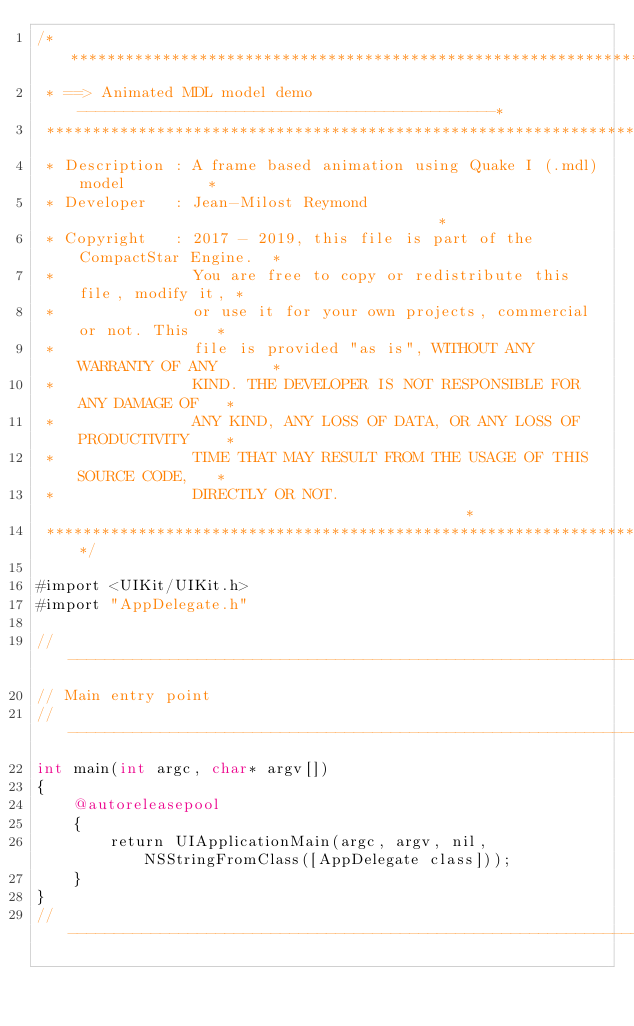<code> <loc_0><loc_0><loc_500><loc_500><_ObjectiveC_>/****************************************************************************
 * ==> Animated MDL model demo ---------------------------------------------*
 ****************************************************************************
 * Description : A frame based animation using Quake I (.mdl) model         *
 * Developer   : Jean-Milost Reymond                                        *
 * Copyright   : 2017 - 2019, this file is part of the CompactStar Engine.  *
 *               You are free to copy or redistribute this file, modify it, *
 *               or use it for your own projects, commercial or not. This   *
 *               file is provided "as is", WITHOUT ANY WARRANTY OF ANY      *
 *               KIND. THE DEVELOPER IS NOT RESPONSIBLE FOR ANY DAMAGE OF   *
 *               ANY KIND, ANY LOSS OF DATA, OR ANY LOSS OF PRODUCTIVITY    *
 *               TIME THAT MAY RESULT FROM THE USAGE OF THIS SOURCE CODE,   *
 *               DIRECTLY OR NOT.                                           *
 ****************************************************************************/

#import <UIKit/UIKit.h>
#import "AppDelegate.h"

//---------------------------------------------------------------------------
// Main entry point
//---------------------------------------------------------------------------
int main(int argc, char* argv[])
{
    @autoreleasepool
    {
        return UIApplicationMain(argc, argv, nil, NSStringFromClass([AppDelegate class]));
    }
}
//---------------------------------------------------------------------------
</code> 